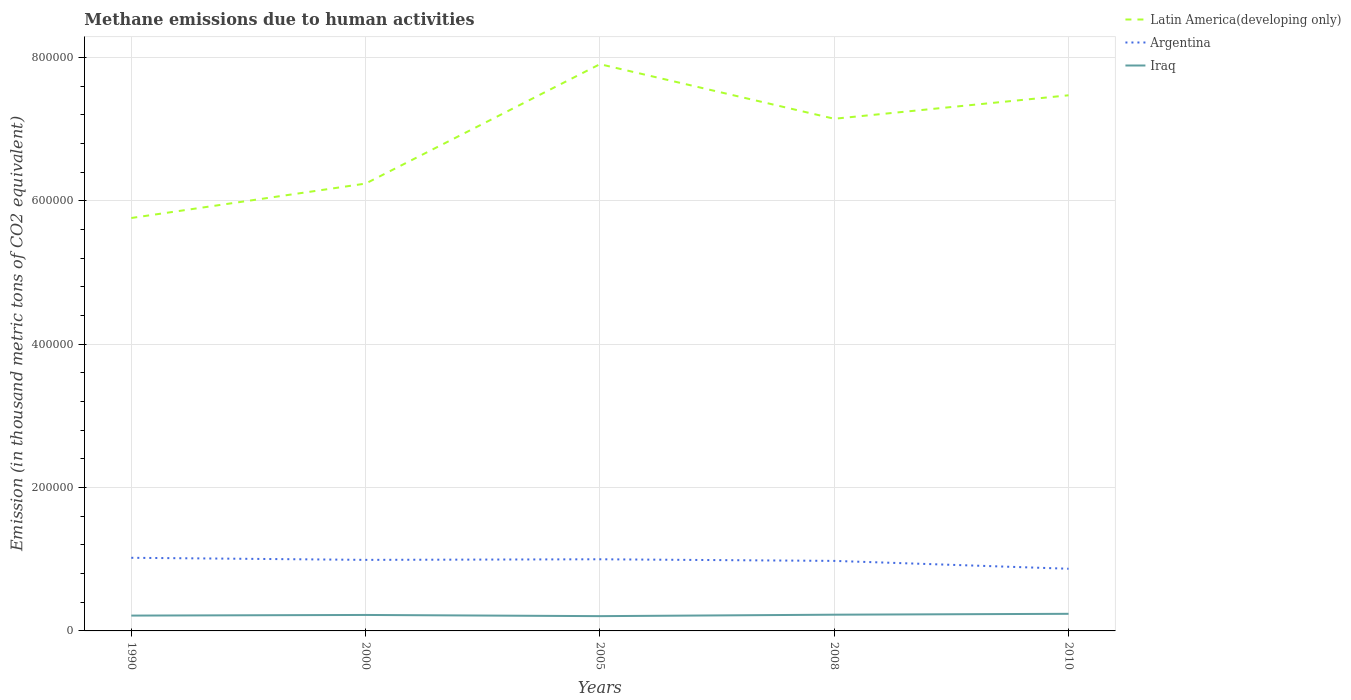Does the line corresponding to Argentina intersect with the line corresponding to Iraq?
Your answer should be very brief. No. Is the number of lines equal to the number of legend labels?
Your answer should be very brief. Yes. Across all years, what is the maximum amount of methane emitted in Latin America(developing only)?
Offer a very short reply. 5.76e+05. What is the total amount of methane emitted in Iraq in the graph?
Make the answer very short. 1660.9. What is the difference between the highest and the second highest amount of methane emitted in Iraq?
Make the answer very short. 3245.7. What is the difference between the highest and the lowest amount of methane emitted in Argentina?
Your answer should be very brief. 4. Is the amount of methane emitted in Iraq strictly greater than the amount of methane emitted in Latin America(developing only) over the years?
Your response must be concise. Yes. How many lines are there?
Offer a very short reply. 3. What is the difference between two consecutive major ticks on the Y-axis?
Offer a very short reply. 2.00e+05. Where does the legend appear in the graph?
Your answer should be very brief. Top right. What is the title of the graph?
Provide a succinct answer. Methane emissions due to human activities. Does "Costa Rica" appear as one of the legend labels in the graph?
Provide a short and direct response. No. What is the label or title of the X-axis?
Keep it short and to the point. Years. What is the label or title of the Y-axis?
Ensure brevity in your answer.  Emission (in thousand metric tons of CO2 equivalent). What is the Emission (in thousand metric tons of CO2 equivalent) in Latin America(developing only) in 1990?
Your answer should be very brief. 5.76e+05. What is the Emission (in thousand metric tons of CO2 equivalent) of Argentina in 1990?
Ensure brevity in your answer.  1.02e+05. What is the Emission (in thousand metric tons of CO2 equivalent) in Iraq in 1990?
Ensure brevity in your answer.  2.14e+04. What is the Emission (in thousand metric tons of CO2 equivalent) in Latin America(developing only) in 2000?
Keep it short and to the point. 6.24e+05. What is the Emission (in thousand metric tons of CO2 equivalent) in Argentina in 2000?
Offer a very short reply. 9.91e+04. What is the Emission (in thousand metric tons of CO2 equivalent) in Iraq in 2000?
Your answer should be compact. 2.23e+04. What is the Emission (in thousand metric tons of CO2 equivalent) in Latin America(developing only) in 2005?
Provide a short and direct response. 7.91e+05. What is the Emission (in thousand metric tons of CO2 equivalent) of Argentina in 2005?
Your answer should be compact. 1.00e+05. What is the Emission (in thousand metric tons of CO2 equivalent) of Iraq in 2005?
Your response must be concise. 2.06e+04. What is the Emission (in thousand metric tons of CO2 equivalent) of Latin America(developing only) in 2008?
Ensure brevity in your answer.  7.15e+05. What is the Emission (in thousand metric tons of CO2 equivalent) in Argentina in 2008?
Ensure brevity in your answer.  9.77e+04. What is the Emission (in thousand metric tons of CO2 equivalent) in Iraq in 2008?
Offer a terse response. 2.26e+04. What is the Emission (in thousand metric tons of CO2 equivalent) of Latin America(developing only) in 2010?
Keep it short and to the point. 7.47e+05. What is the Emission (in thousand metric tons of CO2 equivalent) of Argentina in 2010?
Your response must be concise. 8.67e+04. What is the Emission (in thousand metric tons of CO2 equivalent) of Iraq in 2010?
Ensure brevity in your answer.  2.39e+04. Across all years, what is the maximum Emission (in thousand metric tons of CO2 equivalent) in Latin America(developing only)?
Provide a short and direct response. 7.91e+05. Across all years, what is the maximum Emission (in thousand metric tons of CO2 equivalent) of Argentina?
Offer a terse response. 1.02e+05. Across all years, what is the maximum Emission (in thousand metric tons of CO2 equivalent) of Iraq?
Your answer should be compact. 2.39e+04. Across all years, what is the minimum Emission (in thousand metric tons of CO2 equivalent) in Latin America(developing only)?
Your response must be concise. 5.76e+05. Across all years, what is the minimum Emission (in thousand metric tons of CO2 equivalent) of Argentina?
Your response must be concise. 8.67e+04. Across all years, what is the minimum Emission (in thousand metric tons of CO2 equivalent) of Iraq?
Provide a short and direct response. 2.06e+04. What is the total Emission (in thousand metric tons of CO2 equivalent) in Latin America(developing only) in the graph?
Your response must be concise. 3.45e+06. What is the total Emission (in thousand metric tons of CO2 equivalent) of Argentina in the graph?
Provide a short and direct response. 4.86e+05. What is the total Emission (in thousand metric tons of CO2 equivalent) of Iraq in the graph?
Ensure brevity in your answer.  1.11e+05. What is the difference between the Emission (in thousand metric tons of CO2 equivalent) in Latin America(developing only) in 1990 and that in 2000?
Offer a terse response. -4.80e+04. What is the difference between the Emission (in thousand metric tons of CO2 equivalent) of Argentina in 1990 and that in 2000?
Make the answer very short. 2891.1. What is the difference between the Emission (in thousand metric tons of CO2 equivalent) in Iraq in 1990 and that in 2000?
Keep it short and to the point. -893.7. What is the difference between the Emission (in thousand metric tons of CO2 equivalent) in Latin America(developing only) in 1990 and that in 2005?
Give a very brief answer. -2.15e+05. What is the difference between the Emission (in thousand metric tons of CO2 equivalent) of Argentina in 1990 and that in 2005?
Your response must be concise. 2067.7. What is the difference between the Emission (in thousand metric tons of CO2 equivalent) in Iraq in 1990 and that in 2005?
Ensure brevity in your answer.  767.2. What is the difference between the Emission (in thousand metric tons of CO2 equivalent) in Latin America(developing only) in 1990 and that in 2008?
Offer a terse response. -1.38e+05. What is the difference between the Emission (in thousand metric tons of CO2 equivalent) in Argentina in 1990 and that in 2008?
Give a very brief answer. 4321.5. What is the difference between the Emission (in thousand metric tons of CO2 equivalent) in Iraq in 1990 and that in 2008?
Ensure brevity in your answer.  -1244.7. What is the difference between the Emission (in thousand metric tons of CO2 equivalent) of Latin America(developing only) in 1990 and that in 2010?
Make the answer very short. -1.71e+05. What is the difference between the Emission (in thousand metric tons of CO2 equivalent) of Argentina in 1990 and that in 2010?
Make the answer very short. 1.53e+04. What is the difference between the Emission (in thousand metric tons of CO2 equivalent) of Iraq in 1990 and that in 2010?
Your answer should be compact. -2478.5. What is the difference between the Emission (in thousand metric tons of CO2 equivalent) of Latin America(developing only) in 2000 and that in 2005?
Offer a very short reply. -1.67e+05. What is the difference between the Emission (in thousand metric tons of CO2 equivalent) of Argentina in 2000 and that in 2005?
Make the answer very short. -823.4. What is the difference between the Emission (in thousand metric tons of CO2 equivalent) of Iraq in 2000 and that in 2005?
Ensure brevity in your answer.  1660.9. What is the difference between the Emission (in thousand metric tons of CO2 equivalent) of Latin America(developing only) in 2000 and that in 2008?
Ensure brevity in your answer.  -9.04e+04. What is the difference between the Emission (in thousand metric tons of CO2 equivalent) in Argentina in 2000 and that in 2008?
Provide a short and direct response. 1430.4. What is the difference between the Emission (in thousand metric tons of CO2 equivalent) of Iraq in 2000 and that in 2008?
Your response must be concise. -351. What is the difference between the Emission (in thousand metric tons of CO2 equivalent) of Latin America(developing only) in 2000 and that in 2010?
Your answer should be very brief. -1.23e+05. What is the difference between the Emission (in thousand metric tons of CO2 equivalent) of Argentina in 2000 and that in 2010?
Make the answer very short. 1.24e+04. What is the difference between the Emission (in thousand metric tons of CO2 equivalent) in Iraq in 2000 and that in 2010?
Your answer should be very brief. -1584.8. What is the difference between the Emission (in thousand metric tons of CO2 equivalent) of Latin America(developing only) in 2005 and that in 2008?
Your response must be concise. 7.62e+04. What is the difference between the Emission (in thousand metric tons of CO2 equivalent) in Argentina in 2005 and that in 2008?
Your response must be concise. 2253.8. What is the difference between the Emission (in thousand metric tons of CO2 equivalent) in Iraq in 2005 and that in 2008?
Your response must be concise. -2011.9. What is the difference between the Emission (in thousand metric tons of CO2 equivalent) in Latin America(developing only) in 2005 and that in 2010?
Your answer should be compact. 4.34e+04. What is the difference between the Emission (in thousand metric tons of CO2 equivalent) in Argentina in 2005 and that in 2010?
Keep it short and to the point. 1.32e+04. What is the difference between the Emission (in thousand metric tons of CO2 equivalent) in Iraq in 2005 and that in 2010?
Keep it short and to the point. -3245.7. What is the difference between the Emission (in thousand metric tons of CO2 equivalent) of Latin America(developing only) in 2008 and that in 2010?
Give a very brief answer. -3.27e+04. What is the difference between the Emission (in thousand metric tons of CO2 equivalent) in Argentina in 2008 and that in 2010?
Your answer should be compact. 1.10e+04. What is the difference between the Emission (in thousand metric tons of CO2 equivalent) in Iraq in 2008 and that in 2010?
Provide a short and direct response. -1233.8. What is the difference between the Emission (in thousand metric tons of CO2 equivalent) of Latin America(developing only) in 1990 and the Emission (in thousand metric tons of CO2 equivalent) of Argentina in 2000?
Ensure brevity in your answer.  4.77e+05. What is the difference between the Emission (in thousand metric tons of CO2 equivalent) of Latin America(developing only) in 1990 and the Emission (in thousand metric tons of CO2 equivalent) of Iraq in 2000?
Give a very brief answer. 5.54e+05. What is the difference between the Emission (in thousand metric tons of CO2 equivalent) in Argentina in 1990 and the Emission (in thousand metric tons of CO2 equivalent) in Iraq in 2000?
Provide a short and direct response. 7.97e+04. What is the difference between the Emission (in thousand metric tons of CO2 equivalent) of Latin America(developing only) in 1990 and the Emission (in thousand metric tons of CO2 equivalent) of Argentina in 2005?
Your answer should be compact. 4.76e+05. What is the difference between the Emission (in thousand metric tons of CO2 equivalent) in Latin America(developing only) in 1990 and the Emission (in thousand metric tons of CO2 equivalent) in Iraq in 2005?
Keep it short and to the point. 5.55e+05. What is the difference between the Emission (in thousand metric tons of CO2 equivalent) in Argentina in 1990 and the Emission (in thousand metric tons of CO2 equivalent) in Iraq in 2005?
Your answer should be very brief. 8.14e+04. What is the difference between the Emission (in thousand metric tons of CO2 equivalent) in Latin America(developing only) in 1990 and the Emission (in thousand metric tons of CO2 equivalent) in Argentina in 2008?
Make the answer very short. 4.78e+05. What is the difference between the Emission (in thousand metric tons of CO2 equivalent) in Latin America(developing only) in 1990 and the Emission (in thousand metric tons of CO2 equivalent) in Iraq in 2008?
Keep it short and to the point. 5.53e+05. What is the difference between the Emission (in thousand metric tons of CO2 equivalent) of Argentina in 1990 and the Emission (in thousand metric tons of CO2 equivalent) of Iraq in 2008?
Provide a short and direct response. 7.94e+04. What is the difference between the Emission (in thousand metric tons of CO2 equivalent) of Latin America(developing only) in 1990 and the Emission (in thousand metric tons of CO2 equivalent) of Argentina in 2010?
Your answer should be very brief. 4.89e+05. What is the difference between the Emission (in thousand metric tons of CO2 equivalent) in Latin America(developing only) in 1990 and the Emission (in thousand metric tons of CO2 equivalent) in Iraq in 2010?
Offer a very short reply. 5.52e+05. What is the difference between the Emission (in thousand metric tons of CO2 equivalent) in Argentina in 1990 and the Emission (in thousand metric tons of CO2 equivalent) in Iraq in 2010?
Your response must be concise. 7.81e+04. What is the difference between the Emission (in thousand metric tons of CO2 equivalent) of Latin America(developing only) in 2000 and the Emission (in thousand metric tons of CO2 equivalent) of Argentina in 2005?
Make the answer very short. 5.24e+05. What is the difference between the Emission (in thousand metric tons of CO2 equivalent) in Latin America(developing only) in 2000 and the Emission (in thousand metric tons of CO2 equivalent) in Iraq in 2005?
Keep it short and to the point. 6.03e+05. What is the difference between the Emission (in thousand metric tons of CO2 equivalent) in Argentina in 2000 and the Emission (in thousand metric tons of CO2 equivalent) in Iraq in 2005?
Your answer should be very brief. 7.85e+04. What is the difference between the Emission (in thousand metric tons of CO2 equivalent) of Latin America(developing only) in 2000 and the Emission (in thousand metric tons of CO2 equivalent) of Argentina in 2008?
Offer a terse response. 5.26e+05. What is the difference between the Emission (in thousand metric tons of CO2 equivalent) of Latin America(developing only) in 2000 and the Emission (in thousand metric tons of CO2 equivalent) of Iraq in 2008?
Offer a terse response. 6.01e+05. What is the difference between the Emission (in thousand metric tons of CO2 equivalent) of Argentina in 2000 and the Emission (in thousand metric tons of CO2 equivalent) of Iraq in 2008?
Your answer should be very brief. 7.65e+04. What is the difference between the Emission (in thousand metric tons of CO2 equivalent) in Latin America(developing only) in 2000 and the Emission (in thousand metric tons of CO2 equivalent) in Argentina in 2010?
Your answer should be very brief. 5.37e+05. What is the difference between the Emission (in thousand metric tons of CO2 equivalent) of Latin America(developing only) in 2000 and the Emission (in thousand metric tons of CO2 equivalent) of Iraq in 2010?
Offer a terse response. 6.00e+05. What is the difference between the Emission (in thousand metric tons of CO2 equivalent) of Argentina in 2000 and the Emission (in thousand metric tons of CO2 equivalent) of Iraq in 2010?
Ensure brevity in your answer.  7.53e+04. What is the difference between the Emission (in thousand metric tons of CO2 equivalent) in Latin America(developing only) in 2005 and the Emission (in thousand metric tons of CO2 equivalent) in Argentina in 2008?
Ensure brevity in your answer.  6.93e+05. What is the difference between the Emission (in thousand metric tons of CO2 equivalent) in Latin America(developing only) in 2005 and the Emission (in thousand metric tons of CO2 equivalent) in Iraq in 2008?
Offer a very short reply. 7.68e+05. What is the difference between the Emission (in thousand metric tons of CO2 equivalent) in Argentina in 2005 and the Emission (in thousand metric tons of CO2 equivalent) in Iraq in 2008?
Provide a succinct answer. 7.73e+04. What is the difference between the Emission (in thousand metric tons of CO2 equivalent) in Latin America(developing only) in 2005 and the Emission (in thousand metric tons of CO2 equivalent) in Argentina in 2010?
Ensure brevity in your answer.  7.04e+05. What is the difference between the Emission (in thousand metric tons of CO2 equivalent) of Latin America(developing only) in 2005 and the Emission (in thousand metric tons of CO2 equivalent) of Iraq in 2010?
Provide a succinct answer. 7.67e+05. What is the difference between the Emission (in thousand metric tons of CO2 equivalent) in Argentina in 2005 and the Emission (in thousand metric tons of CO2 equivalent) in Iraq in 2010?
Your answer should be compact. 7.61e+04. What is the difference between the Emission (in thousand metric tons of CO2 equivalent) in Latin America(developing only) in 2008 and the Emission (in thousand metric tons of CO2 equivalent) in Argentina in 2010?
Make the answer very short. 6.28e+05. What is the difference between the Emission (in thousand metric tons of CO2 equivalent) of Latin America(developing only) in 2008 and the Emission (in thousand metric tons of CO2 equivalent) of Iraq in 2010?
Ensure brevity in your answer.  6.91e+05. What is the difference between the Emission (in thousand metric tons of CO2 equivalent) in Argentina in 2008 and the Emission (in thousand metric tons of CO2 equivalent) in Iraq in 2010?
Provide a succinct answer. 7.38e+04. What is the average Emission (in thousand metric tons of CO2 equivalent) in Latin America(developing only) per year?
Give a very brief answer. 6.91e+05. What is the average Emission (in thousand metric tons of CO2 equivalent) of Argentina per year?
Keep it short and to the point. 9.71e+04. What is the average Emission (in thousand metric tons of CO2 equivalent) of Iraq per year?
Make the answer very short. 2.22e+04. In the year 1990, what is the difference between the Emission (in thousand metric tons of CO2 equivalent) in Latin America(developing only) and Emission (in thousand metric tons of CO2 equivalent) in Argentina?
Your answer should be very brief. 4.74e+05. In the year 1990, what is the difference between the Emission (in thousand metric tons of CO2 equivalent) of Latin America(developing only) and Emission (in thousand metric tons of CO2 equivalent) of Iraq?
Ensure brevity in your answer.  5.55e+05. In the year 1990, what is the difference between the Emission (in thousand metric tons of CO2 equivalent) of Argentina and Emission (in thousand metric tons of CO2 equivalent) of Iraq?
Provide a short and direct response. 8.06e+04. In the year 2000, what is the difference between the Emission (in thousand metric tons of CO2 equivalent) in Latin America(developing only) and Emission (in thousand metric tons of CO2 equivalent) in Argentina?
Make the answer very short. 5.25e+05. In the year 2000, what is the difference between the Emission (in thousand metric tons of CO2 equivalent) in Latin America(developing only) and Emission (in thousand metric tons of CO2 equivalent) in Iraq?
Keep it short and to the point. 6.02e+05. In the year 2000, what is the difference between the Emission (in thousand metric tons of CO2 equivalent) of Argentina and Emission (in thousand metric tons of CO2 equivalent) of Iraq?
Your response must be concise. 7.68e+04. In the year 2005, what is the difference between the Emission (in thousand metric tons of CO2 equivalent) of Latin America(developing only) and Emission (in thousand metric tons of CO2 equivalent) of Argentina?
Keep it short and to the point. 6.91e+05. In the year 2005, what is the difference between the Emission (in thousand metric tons of CO2 equivalent) in Latin America(developing only) and Emission (in thousand metric tons of CO2 equivalent) in Iraq?
Make the answer very short. 7.70e+05. In the year 2005, what is the difference between the Emission (in thousand metric tons of CO2 equivalent) in Argentina and Emission (in thousand metric tons of CO2 equivalent) in Iraq?
Ensure brevity in your answer.  7.93e+04. In the year 2008, what is the difference between the Emission (in thousand metric tons of CO2 equivalent) in Latin America(developing only) and Emission (in thousand metric tons of CO2 equivalent) in Argentina?
Your answer should be very brief. 6.17e+05. In the year 2008, what is the difference between the Emission (in thousand metric tons of CO2 equivalent) of Latin America(developing only) and Emission (in thousand metric tons of CO2 equivalent) of Iraq?
Provide a short and direct response. 6.92e+05. In the year 2008, what is the difference between the Emission (in thousand metric tons of CO2 equivalent) of Argentina and Emission (in thousand metric tons of CO2 equivalent) of Iraq?
Offer a very short reply. 7.51e+04. In the year 2010, what is the difference between the Emission (in thousand metric tons of CO2 equivalent) of Latin America(developing only) and Emission (in thousand metric tons of CO2 equivalent) of Argentina?
Provide a succinct answer. 6.61e+05. In the year 2010, what is the difference between the Emission (in thousand metric tons of CO2 equivalent) in Latin America(developing only) and Emission (in thousand metric tons of CO2 equivalent) in Iraq?
Offer a terse response. 7.23e+05. In the year 2010, what is the difference between the Emission (in thousand metric tons of CO2 equivalent) of Argentina and Emission (in thousand metric tons of CO2 equivalent) of Iraq?
Your answer should be compact. 6.29e+04. What is the ratio of the Emission (in thousand metric tons of CO2 equivalent) in Latin America(developing only) in 1990 to that in 2000?
Offer a very short reply. 0.92. What is the ratio of the Emission (in thousand metric tons of CO2 equivalent) in Argentina in 1990 to that in 2000?
Your answer should be very brief. 1.03. What is the ratio of the Emission (in thousand metric tons of CO2 equivalent) in Iraq in 1990 to that in 2000?
Offer a terse response. 0.96. What is the ratio of the Emission (in thousand metric tons of CO2 equivalent) in Latin America(developing only) in 1990 to that in 2005?
Your answer should be very brief. 0.73. What is the ratio of the Emission (in thousand metric tons of CO2 equivalent) of Argentina in 1990 to that in 2005?
Your answer should be compact. 1.02. What is the ratio of the Emission (in thousand metric tons of CO2 equivalent) of Iraq in 1990 to that in 2005?
Provide a succinct answer. 1.04. What is the ratio of the Emission (in thousand metric tons of CO2 equivalent) of Latin America(developing only) in 1990 to that in 2008?
Give a very brief answer. 0.81. What is the ratio of the Emission (in thousand metric tons of CO2 equivalent) of Argentina in 1990 to that in 2008?
Offer a terse response. 1.04. What is the ratio of the Emission (in thousand metric tons of CO2 equivalent) in Iraq in 1990 to that in 2008?
Offer a terse response. 0.94. What is the ratio of the Emission (in thousand metric tons of CO2 equivalent) in Latin America(developing only) in 1990 to that in 2010?
Provide a short and direct response. 0.77. What is the ratio of the Emission (in thousand metric tons of CO2 equivalent) of Argentina in 1990 to that in 2010?
Provide a succinct answer. 1.18. What is the ratio of the Emission (in thousand metric tons of CO2 equivalent) of Iraq in 1990 to that in 2010?
Keep it short and to the point. 0.9. What is the ratio of the Emission (in thousand metric tons of CO2 equivalent) of Latin America(developing only) in 2000 to that in 2005?
Offer a terse response. 0.79. What is the ratio of the Emission (in thousand metric tons of CO2 equivalent) of Argentina in 2000 to that in 2005?
Make the answer very short. 0.99. What is the ratio of the Emission (in thousand metric tons of CO2 equivalent) in Iraq in 2000 to that in 2005?
Ensure brevity in your answer.  1.08. What is the ratio of the Emission (in thousand metric tons of CO2 equivalent) of Latin America(developing only) in 2000 to that in 2008?
Give a very brief answer. 0.87. What is the ratio of the Emission (in thousand metric tons of CO2 equivalent) of Argentina in 2000 to that in 2008?
Your answer should be very brief. 1.01. What is the ratio of the Emission (in thousand metric tons of CO2 equivalent) of Iraq in 2000 to that in 2008?
Ensure brevity in your answer.  0.98. What is the ratio of the Emission (in thousand metric tons of CO2 equivalent) of Latin America(developing only) in 2000 to that in 2010?
Your response must be concise. 0.84. What is the ratio of the Emission (in thousand metric tons of CO2 equivalent) in Argentina in 2000 to that in 2010?
Offer a very short reply. 1.14. What is the ratio of the Emission (in thousand metric tons of CO2 equivalent) in Iraq in 2000 to that in 2010?
Your response must be concise. 0.93. What is the ratio of the Emission (in thousand metric tons of CO2 equivalent) in Latin America(developing only) in 2005 to that in 2008?
Keep it short and to the point. 1.11. What is the ratio of the Emission (in thousand metric tons of CO2 equivalent) in Argentina in 2005 to that in 2008?
Make the answer very short. 1.02. What is the ratio of the Emission (in thousand metric tons of CO2 equivalent) in Iraq in 2005 to that in 2008?
Keep it short and to the point. 0.91. What is the ratio of the Emission (in thousand metric tons of CO2 equivalent) in Latin America(developing only) in 2005 to that in 2010?
Offer a very short reply. 1.06. What is the ratio of the Emission (in thousand metric tons of CO2 equivalent) in Argentina in 2005 to that in 2010?
Your answer should be compact. 1.15. What is the ratio of the Emission (in thousand metric tons of CO2 equivalent) of Iraq in 2005 to that in 2010?
Your answer should be compact. 0.86. What is the ratio of the Emission (in thousand metric tons of CO2 equivalent) in Latin America(developing only) in 2008 to that in 2010?
Provide a short and direct response. 0.96. What is the ratio of the Emission (in thousand metric tons of CO2 equivalent) in Argentina in 2008 to that in 2010?
Your answer should be very brief. 1.13. What is the ratio of the Emission (in thousand metric tons of CO2 equivalent) of Iraq in 2008 to that in 2010?
Your answer should be compact. 0.95. What is the difference between the highest and the second highest Emission (in thousand metric tons of CO2 equivalent) in Latin America(developing only)?
Offer a terse response. 4.34e+04. What is the difference between the highest and the second highest Emission (in thousand metric tons of CO2 equivalent) in Argentina?
Ensure brevity in your answer.  2067.7. What is the difference between the highest and the second highest Emission (in thousand metric tons of CO2 equivalent) in Iraq?
Provide a short and direct response. 1233.8. What is the difference between the highest and the lowest Emission (in thousand metric tons of CO2 equivalent) of Latin America(developing only)?
Your response must be concise. 2.15e+05. What is the difference between the highest and the lowest Emission (in thousand metric tons of CO2 equivalent) in Argentina?
Make the answer very short. 1.53e+04. What is the difference between the highest and the lowest Emission (in thousand metric tons of CO2 equivalent) of Iraq?
Keep it short and to the point. 3245.7. 